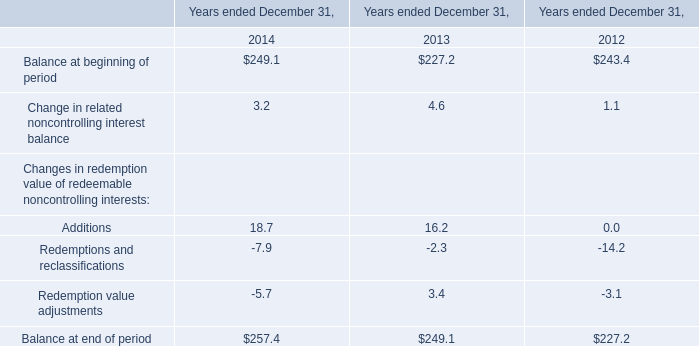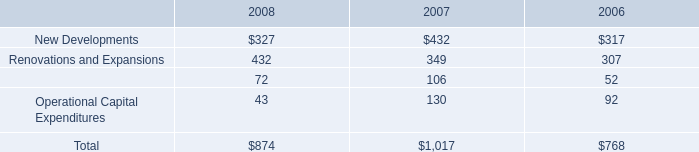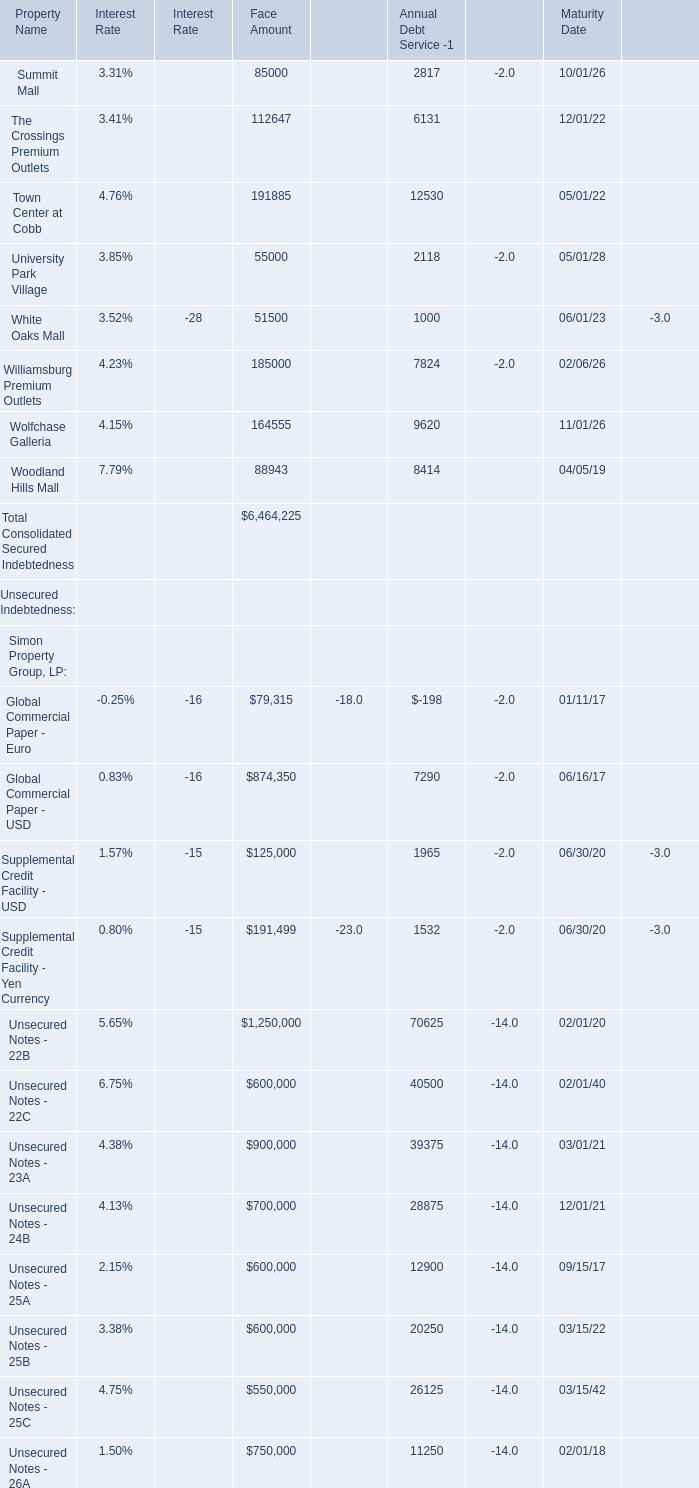How much is the Face Amount for Total Consolidated Secured Indebtedness less than the 50 % of the Total Consolidated Indebtedness at Face Amounts? 
Computations: ((0.5 * 23099450) - 6464225)
Answer: 5085500.0. 